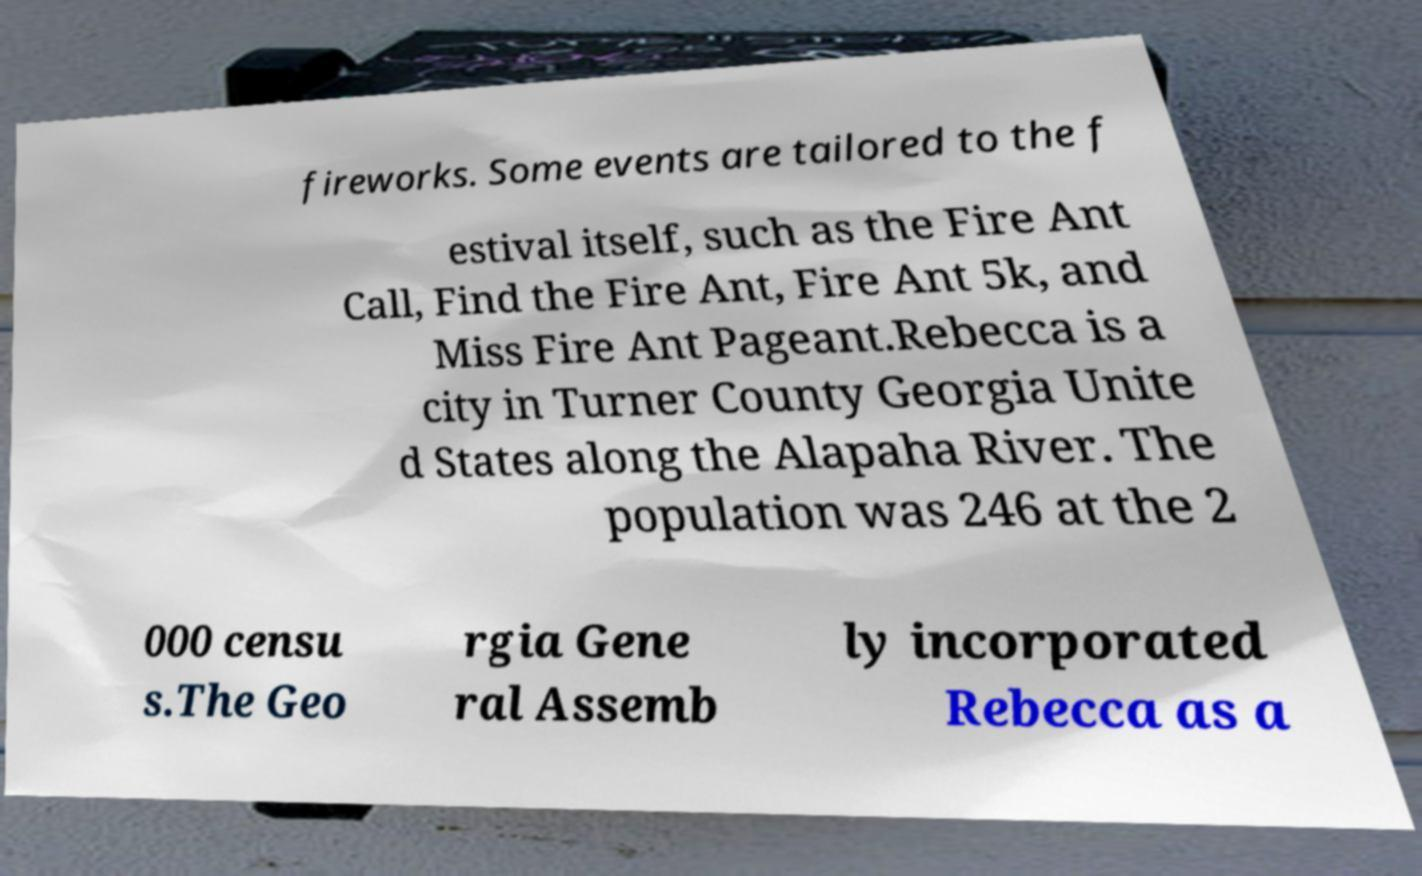Can you read and provide the text displayed in the image?This photo seems to have some interesting text. Can you extract and type it out for me? fireworks. Some events are tailored to the f estival itself, such as the Fire Ant Call, Find the Fire Ant, Fire Ant 5k, and Miss Fire Ant Pageant.Rebecca is a city in Turner County Georgia Unite d States along the Alapaha River. The population was 246 at the 2 000 censu s.The Geo rgia Gene ral Assemb ly incorporated Rebecca as a 